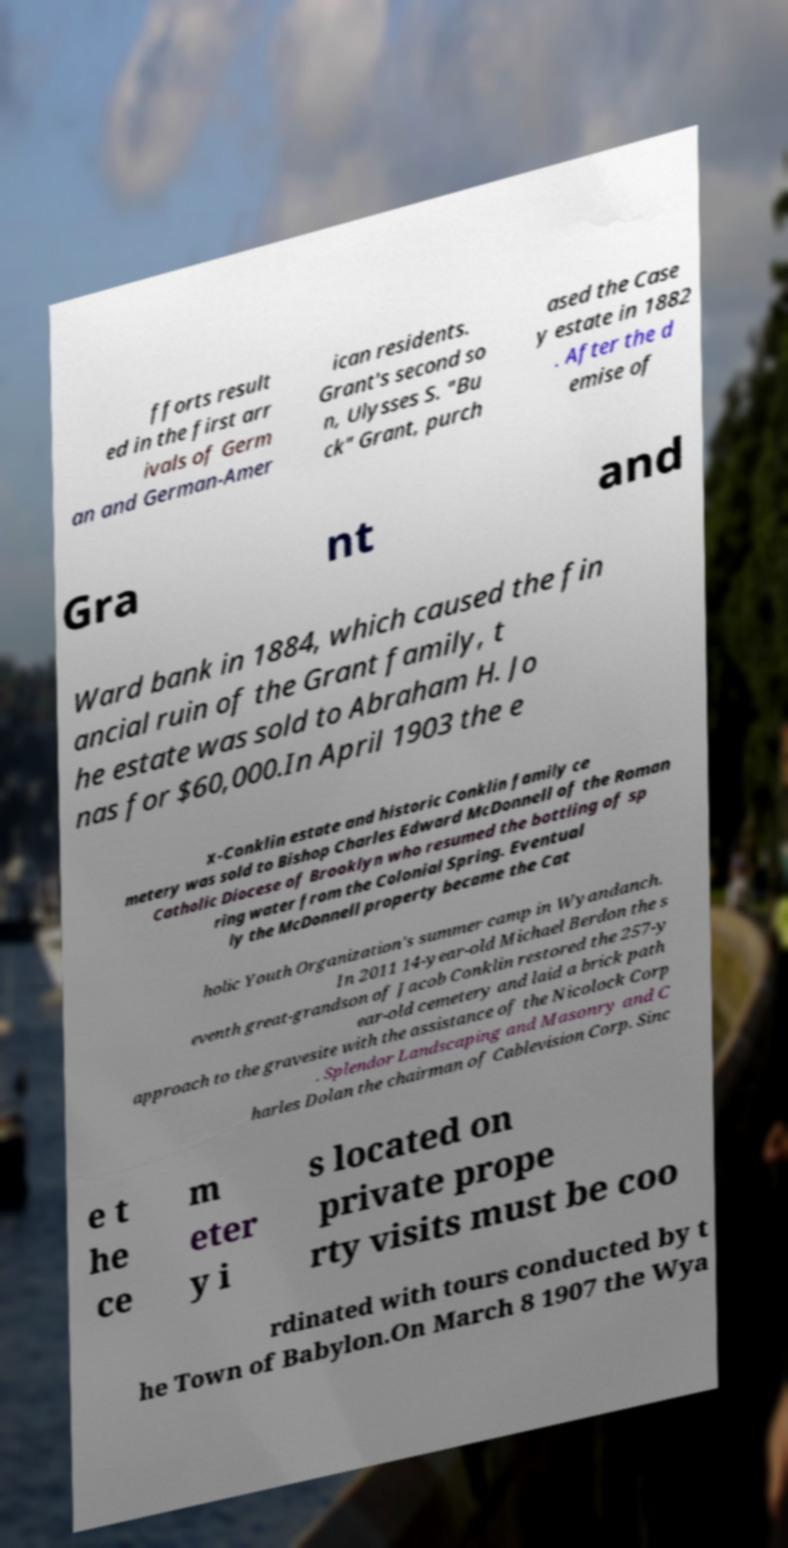For documentation purposes, I need the text within this image transcribed. Could you provide that? fforts result ed in the first arr ivals of Germ an and German-Amer ican residents. Grant's second so n, Ulysses S. "Bu ck" Grant, purch ased the Case y estate in 1882 . After the d emise of Gra nt and Ward bank in 1884, which caused the fin ancial ruin of the Grant family, t he estate was sold to Abraham H. Jo nas for $60,000.In April 1903 the e x-Conklin estate and historic Conklin family ce metery was sold to Bishop Charles Edward McDonnell of the Roman Catholic Diocese of Brooklyn who resumed the bottling of sp ring water from the Colonial Spring. Eventual ly the McDonnell property became the Cat holic Youth Organization's summer camp in Wyandanch. In 2011 14-year-old Michael Berdon the s eventh great-grandson of Jacob Conklin restored the 257-y ear-old cemetery and laid a brick path approach to the gravesite with the assistance of the Nicolock Corp . Splendor Landscaping and Masonry and C harles Dolan the chairman of Cablevision Corp. Sinc e t he ce m eter y i s located on private prope rty visits must be coo rdinated with tours conducted by t he Town of Babylon.On March 8 1907 the Wya 